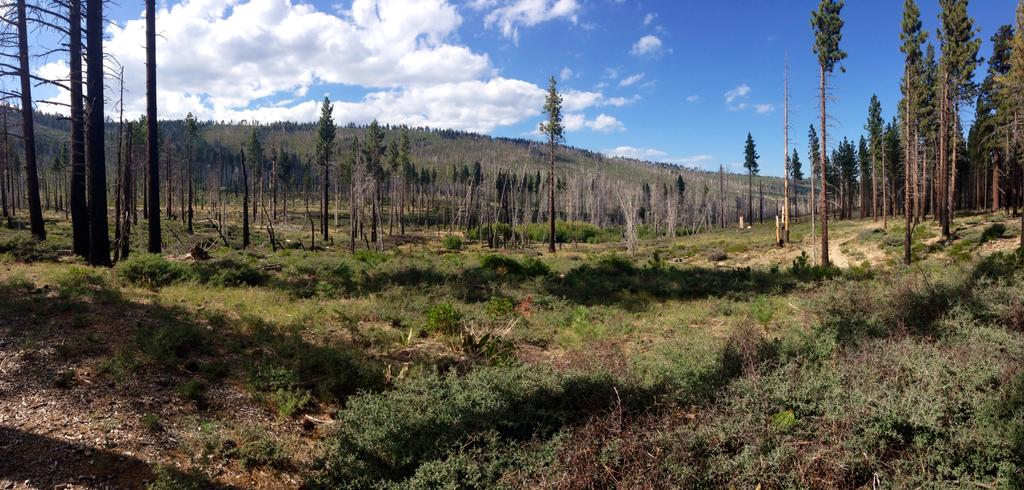What type of ground cover is visible in the image? There is grass on the ground in the image. What can be seen in the distance in the image? There are trees in the background of the image. What is visible in the sky in the image? The sky is visible in the background of the image, and clouds are present. Where is the wire connected to the range in the image? There is no wire or range present in the image; it features grass, trees, and the sky. What type of sofa is visible in the image? There is no sofa present in the image. 